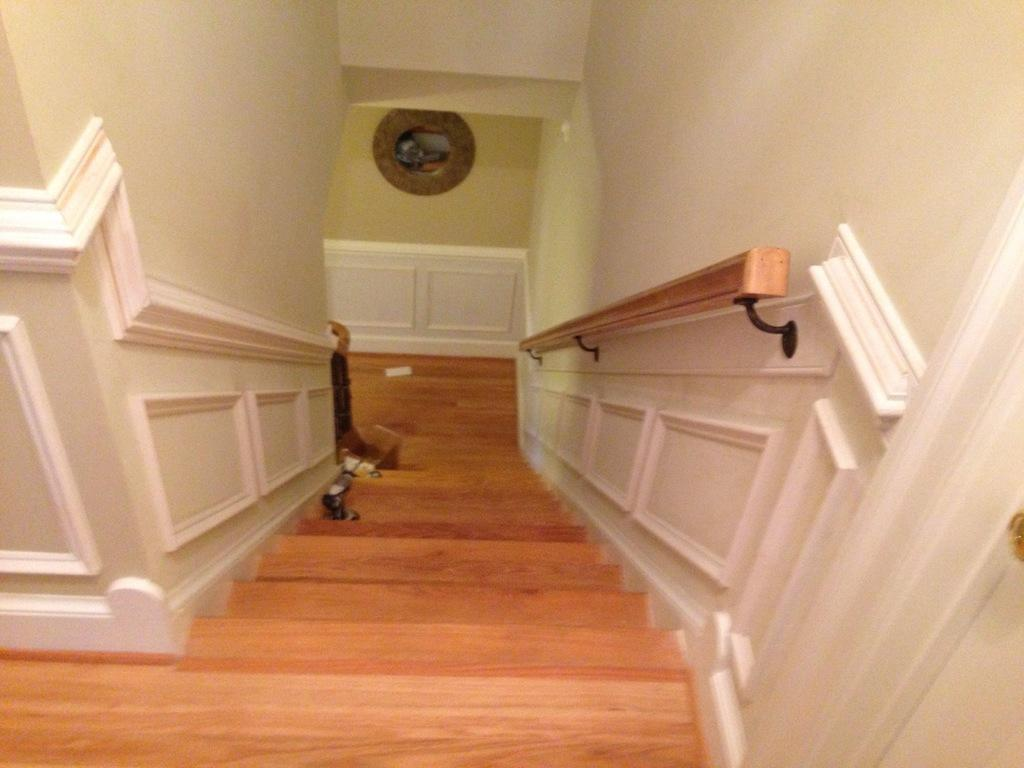What is located in the center of the image? There are stairs in the center of the image. What can be seen on the stairs? There are objects on the stairs. What type of lace can be seen on the bear's paw in the image? There is no bear or lace present in the image; it only features stairs with objects on them. 